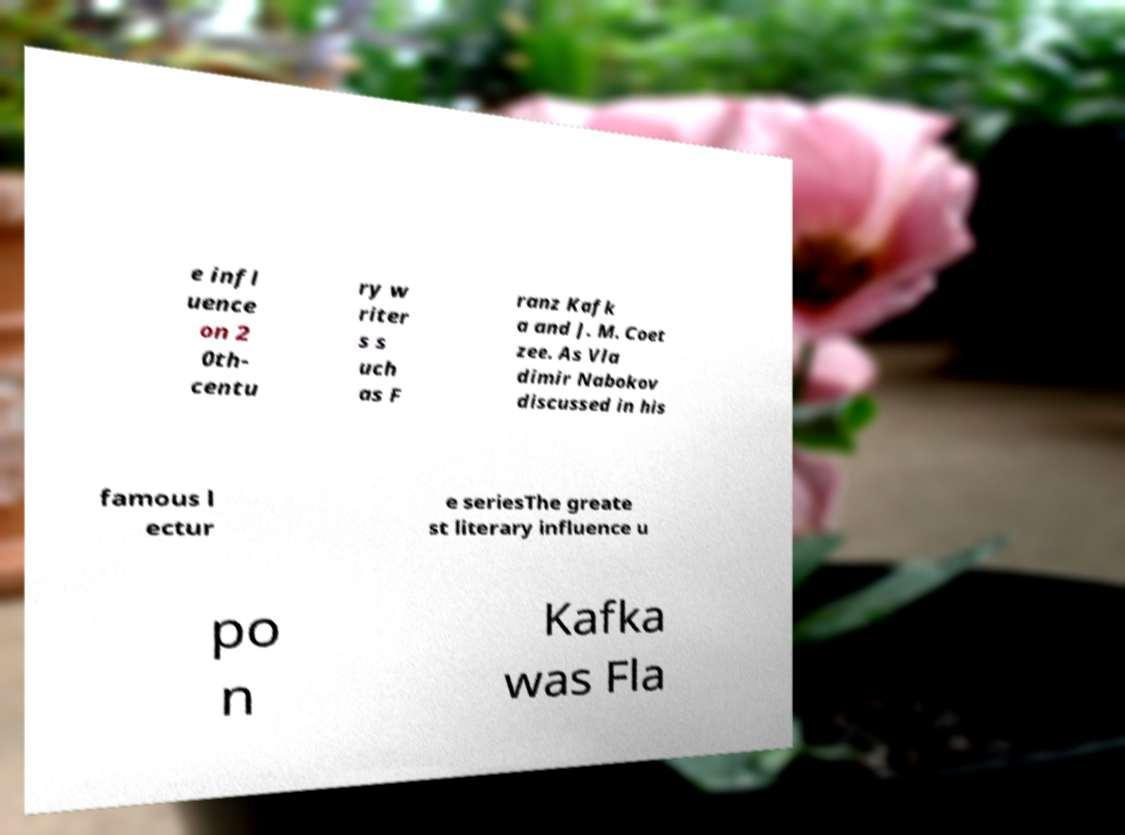Please read and relay the text visible in this image. What does it say? e infl uence on 2 0th- centu ry w riter s s uch as F ranz Kafk a and J. M. Coet zee. As Vla dimir Nabokov discussed in his famous l ectur e seriesThe greate st literary influence u po n Kafka was Fla 